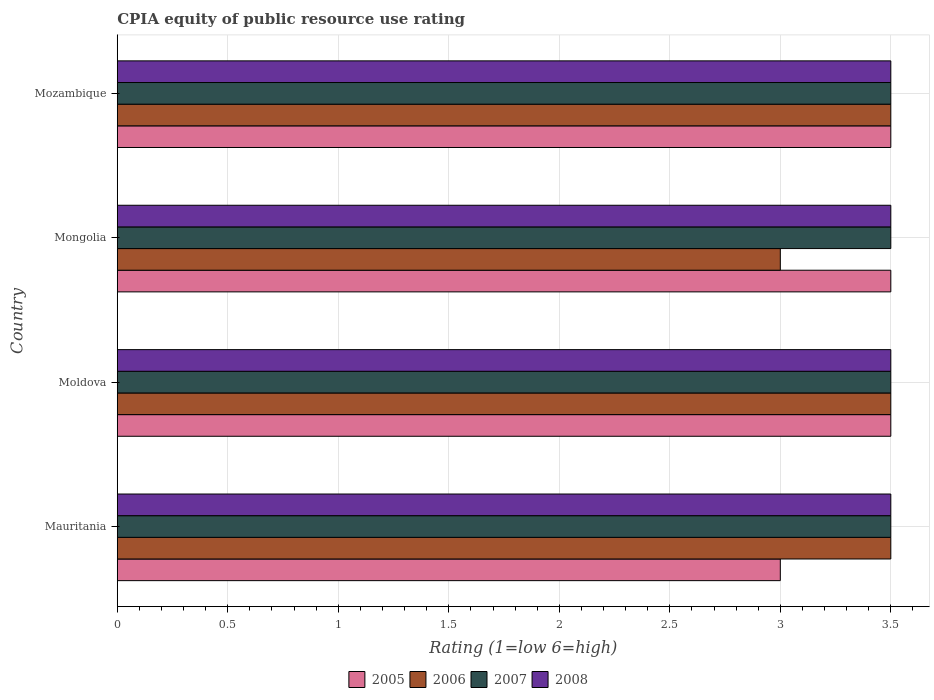How many different coloured bars are there?
Your answer should be very brief. 4. How many groups of bars are there?
Provide a succinct answer. 4. Are the number of bars per tick equal to the number of legend labels?
Your response must be concise. Yes. How many bars are there on the 1st tick from the top?
Keep it short and to the point. 4. How many bars are there on the 4th tick from the bottom?
Provide a short and direct response. 4. What is the label of the 4th group of bars from the top?
Offer a very short reply. Mauritania. What is the CPIA rating in 2007 in Mauritania?
Provide a short and direct response. 3.5. In which country was the CPIA rating in 2006 maximum?
Your response must be concise. Mauritania. In which country was the CPIA rating in 2007 minimum?
Provide a short and direct response. Mauritania. What is the difference between the CPIA rating in 2008 in Mauritania and the CPIA rating in 2006 in Mongolia?
Make the answer very short. 0.5. What is the average CPIA rating in 2005 per country?
Your answer should be very brief. 3.38. What is the difference between the CPIA rating in 2008 and CPIA rating in 2007 in Moldova?
Your answer should be very brief. 0. In how many countries, is the CPIA rating in 2008 greater than 2.7 ?
Provide a succinct answer. 4. Is the sum of the CPIA rating in 2005 in Mauritania and Mozambique greater than the maximum CPIA rating in 2007 across all countries?
Your answer should be very brief. Yes. Is it the case that in every country, the sum of the CPIA rating in 2007 and CPIA rating in 2005 is greater than the sum of CPIA rating in 2006 and CPIA rating in 2008?
Provide a short and direct response. No. How many bars are there?
Make the answer very short. 16. Are all the bars in the graph horizontal?
Make the answer very short. Yes. How many countries are there in the graph?
Offer a terse response. 4. Are the values on the major ticks of X-axis written in scientific E-notation?
Your answer should be very brief. No. Does the graph contain any zero values?
Keep it short and to the point. No. Does the graph contain grids?
Offer a very short reply. Yes. Where does the legend appear in the graph?
Give a very brief answer. Bottom center. How are the legend labels stacked?
Make the answer very short. Horizontal. What is the title of the graph?
Make the answer very short. CPIA equity of public resource use rating. Does "1966" appear as one of the legend labels in the graph?
Your answer should be very brief. No. What is the Rating (1=low 6=high) of 2005 in Mauritania?
Provide a succinct answer. 3. What is the Rating (1=low 6=high) in 2006 in Mauritania?
Offer a very short reply. 3.5. What is the Rating (1=low 6=high) of 2008 in Mauritania?
Your response must be concise. 3.5. What is the Rating (1=low 6=high) of 2005 in Moldova?
Your answer should be very brief. 3.5. What is the Rating (1=low 6=high) of 2006 in Moldova?
Offer a terse response. 3.5. What is the Rating (1=low 6=high) in 2008 in Mongolia?
Make the answer very short. 3.5. What is the Rating (1=low 6=high) of 2006 in Mozambique?
Your answer should be compact. 3.5. What is the Rating (1=low 6=high) in 2007 in Mozambique?
Your response must be concise. 3.5. Across all countries, what is the maximum Rating (1=low 6=high) of 2005?
Your response must be concise. 3.5. Across all countries, what is the maximum Rating (1=low 6=high) of 2006?
Provide a short and direct response. 3.5. Across all countries, what is the maximum Rating (1=low 6=high) in 2008?
Make the answer very short. 3.5. Across all countries, what is the minimum Rating (1=low 6=high) in 2005?
Provide a short and direct response. 3. Across all countries, what is the minimum Rating (1=low 6=high) in 2006?
Keep it short and to the point. 3. Across all countries, what is the minimum Rating (1=low 6=high) in 2007?
Your answer should be very brief. 3.5. What is the total Rating (1=low 6=high) of 2005 in the graph?
Provide a short and direct response. 13.5. What is the total Rating (1=low 6=high) in 2006 in the graph?
Your answer should be compact. 13.5. What is the total Rating (1=low 6=high) in 2007 in the graph?
Your response must be concise. 14. What is the total Rating (1=low 6=high) of 2008 in the graph?
Offer a very short reply. 14. What is the difference between the Rating (1=low 6=high) in 2005 in Mauritania and that in Mongolia?
Ensure brevity in your answer.  -0.5. What is the difference between the Rating (1=low 6=high) in 2006 in Mauritania and that in Mongolia?
Offer a very short reply. 0.5. What is the difference between the Rating (1=low 6=high) in 2007 in Mauritania and that in Mongolia?
Make the answer very short. 0. What is the difference between the Rating (1=low 6=high) in 2007 in Mauritania and that in Mozambique?
Offer a very short reply. 0. What is the difference between the Rating (1=low 6=high) in 2005 in Moldova and that in Mongolia?
Your response must be concise. 0. What is the difference between the Rating (1=low 6=high) of 2005 in Moldova and that in Mozambique?
Your answer should be compact. 0. What is the difference between the Rating (1=low 6=high) in 2006 in Moldova and that in Mozambique?
Your answer should be very brief. 0. What is the difference between the Rating (1=low 6=high) of 2006 in Mongolia and that in Mozambique?
Make the answer very short. -0.5. What is the difference between the Rating (1=low 6=high) in 2005 in Mauritania and the Rating (1=low 6=high) in 2008 in Moldova?
Provide a short and direct response. -0.5. What is the difference between the Rating (1=low 6=high) in 2007 in Mauritania and the Rating (1=low 6=high) in 2008 in Moldova?
Make the answer very short. 0. What is the difference between the Rating (1=low 6=high) of 2005 in Mauritania and the Rating (1=low 6=high) of 2006 in Mongolia?
Ensure brevity in your answer.  0. What is the difference between the Rating (1=low 6=high) of 2005 in Mauritania and the Rating (1=low 6=high) of 2007 in Mongolia?
Ensure brevity in your answer.  -0.5. What is the difference between the Rating (1=low 6=high) of 2005 in Mauritania and the Rating (1=low 6=high) of 2007 in Mozambique?
Offer a terse response. -0.5. What is the difference between the Rating (1=low 6=high) in 2005 in Mauritania and the Rating (1=low 6=high) in 2008 in Mozambique?
Keep it short and to the point. -0.5. What is the difference between the Rating (1=low 6=high) of 2007 in Mauritania and the Rating (1=low 6=high) of 2008 in Mozambique?
Provide a succinct answer. 0. What is the difference between the Rating (1=low 6=high) of 2005 in Moldova and the Rating (1=low 6=high) of 2008 in Mongolia?
Provide a succinct answer. 0. What is the difference between the Rating (1=low 6=high) of 2006 in Moldova and the Rating (1=low 6=high) of 2007 in Mongolia?
Give a very brief answer. 0. What is the difference between the Rating (1=low 6=high) of 2007 in Moldova and the Rating (1=low 6=high) of 2008 in Mongolia?
Your response must be concise. 0. What is the difference between the Rating (1=low 6=high) of 2005 in Moldova and the Rating (1=low 6=high) of 2008 in Mozambique?
Offer a terse response. 0. What is the difference between the Rating (1=low 6=high) of 2006 in Moldova and the Rating (1=low 6=high) of 2007 in Mozambique?
Ensure brevity in your answer.  0. What is the difference between the Rating (1=low 6=high) in 2006 in Moldova and the Rating (1=low 6=high) in 2008 in Mozambique?
Your answer should be very brief. 0. What is the difference between the Rating (1=low 6=high) in 2007 in Moldova and the Rating (1=low 6=high) in 2008 in Mozambique?
Ensure brevity in your answer.  0. What is the difference between the Rating (1=low 6=high) in 2005 in Mongolia and the Rating (1=low 6=high) in 2006 in Mozambique?
Make the answer very short. 0. What is the difference between the Rating (1=low 6=high) of 2005 in Mongolia and the Rating (1=low 6=high) of 2007 in Mozambique?
Your response must be concise. 0. What is the difference between the Rating (1=low 6=high) in 2005 in Mongolia and the Rating (1=low 6=high) in 2008 in Mozambique?
Your answer should be very brief. 0. What is the difference between the Rating (1=low 6=high) of 2006 in Mongolia and the Rating (1=low 6=high) of 2008 in Mozambique?
Make the answer very short. -0.5. What is the difference between the Rating (1=low 6=high) in 2007 in Mongolia and the Rating (1=low 6=high) in 2008 in Mozambique?
Provide a short and direct response. 0. What is the average Rating (1=low 6=high) of 2005 per country?
Offer a terse response. 3.38. What is the average Rating (1=low 6=high) of 2006 per country?
Offer a very short reply. 3.38. What is the average Rating (1=low 6=high) in 2008 per country?
Offer a terse response. 3.5. What is the difference between the Rating (1=low 6=high) in 2005 and Rating (1=low 6=high) in 2006 in Mauritania?
Ensure brevity in your answer.  -0.5. What is the difference between the Rating (1=low 6=high) of 2005 and Rating (1=low 6=high) of 2008 in Mauritania?
Provide a short and direct response. -0.5. What is the difference between the Rating (1=low 6=high) in 2006 and Rating (1=low 6=high) in 2008 in Mauritania?
Provide a short and direct response. 0. What is the difference between the Rating (1=low 6=high) in 2007 and Rating (1=low 6=high) in 2008 in Mauritania?
Keep it short and to the point. 0. What is the difference between the Rating (1=low 6=high) of 2005 and Rating (1=low 6=high) of 2007 in Moldova?
Provide a short and direct response. 0. What is the difference between the Rating (1=low 6=high) in 2007 and Rating (1=low 6=high) in 2008 in Moldova?
Offer a terse response. 0. What is the difference between the Rating (1=low 6=high) in 2005 and Rating (1=low 6=high) in 2006 in Mongolia?
Offer a terse response. 0.5. What is the difference between the Rating (1=low 6=high) in 2006 and Rating (1=low 6=high) in 2007 in Mongolia?
Provide a succinct answer. -0.5. What is the difference between the Rating (1=low 6=high) of 2006 and Rating (1=low 6=high) of 2008 in Mongolia?
Your answer should be very brief. -0.5. What is the difference between the Rating (1=low 6=high) in 2007 and Rating (1=low 6=high) in 2008 in Mongolia?
Keep it short and to the point. 0. What is the difference between the Rating (1=low 6=high) of 2005 and Rating (1=low 6=high) of 2007 in Mozambique?
Make the answer very short. 0. What is the difference between the Rating (1=low 6=high) in 2005 and Rating (1=low 6=high) in 2008 in Mozambique?
Offer a very short reply. 0. What is the difference between the Rating (1=low 6=high) of 2006 and Rating (1=low 6=high) of 2008 in Mozambique?
Offer a terse response. 0. What is the difference between the Rating (1=low 6=high) in 2007 and Rating (1=low 6=high) in 2008 in Mozambique?
Give a very brief answer. 0. What is the ratio of the Rating (1=low 6=high) of 2007 in Mauritania to that in Moldova?
Offer a terse response. 1. What is the ratio of the Rating (1=low 6=high) of 2005 in Mauritania to that in Mongolia?
Offer a very short reply. 0.86. What is the ratio of the Rating (1=low 6=high) of 2006 in Mauritania to that in Mongolia?
Offer a very short reply. 1.17. What is the ratio of the Rating (1=low 6=high) of 2005 in Mauritania to that in Mozambique?
Keep it short and to the point. 0.86. What is the ratio of the Rating (1=low 6=high) of 2008 in Mauritania to that in Mozambique?
Your answer should be very brief. 1. What is the ratio of the Rating (1=low 6=high) of 2006 in Moldova to that in Mongolia?
Your answer should be compact. 1.17. What is the ratio of the Rating (1=low 6=high) in 2008 in Moldova to that in Mongolia?
Offer a very short reply. 1. What is the ratio of the Rating (1=low 6=high) of 2005 in Moldova to that in Mozambique?
Make the answer very short. 1. What is the ratio of the Rating (1=low 6=high) of 2006 in Moldova to that in Mozambique?
Your answer should be compact. 1. What is the ratio of the Rating (1=low 6=high) of 2007 in Mongolia to that in Mozambique?
Provide a succinct answer. 1. What is the difference between the highest and the second highest Rating (1=low 6=high) in 2006?
Provide a succinct answer. 0. What is the difference between the highest and the second highest Rating (1=low 6=high) of 2007?
Provide a short and direct response. 0. What is the difference between the highest and the second highest Rating (1=low 6=high) in 2008?
Your answer should be compact. 0. What is the difference between the highest and the lowest Rating (1=low 6=high) in 2006?
Keep it short and to the point. 0.5. What is the difference between the highest and the lowest Rating (1=low 6=high) in 2008?
Ensure brevity in your answer.  0. 